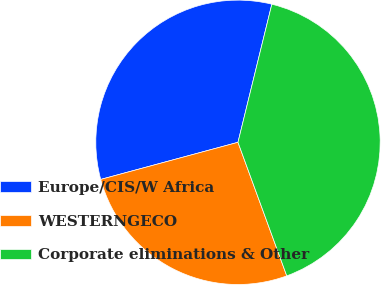Convert chart. <chart><loc_0><loc_0><loc_500><loc_500><pie_chart><fcel>Europe/CIS/W Africa<fcel>WESTERNGECO<fcel>Corporate eliminations & Other<nl><fcel>33.03%<fcel>26.37%<fcel>40.6%<nl></chart> 